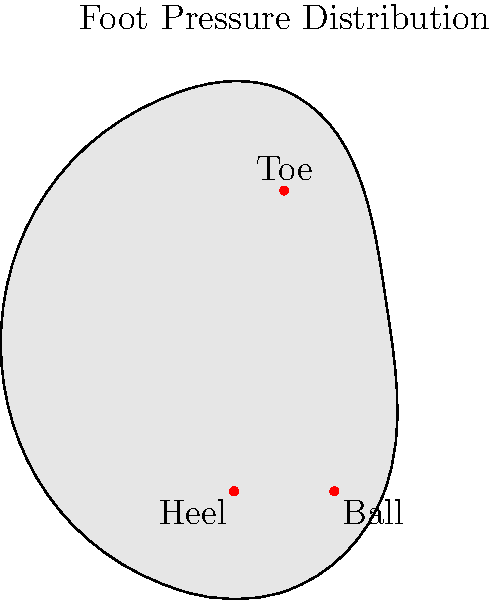When standing for extended periods, which area of the foot typically experiences the highest pressure, as illustrated in the diagram? To understand the pressure distribution on feet when standing for long periods, let's consider the anatomy and function of the foot:

1. The foot has three main weight-bearing areas: the heel, the ball (metatarsal heads), and the toes.

2. When standing, body weight is distributed across these areas, but not equally.

3. The heel and ball of the foot are designed to bear more weight than the toes.

4. The heel has a thick fat pad to absorb shock and pressure.

5. The ball of the foot, specifically the metatarsal heads, bears a significant portion of the body's weight during standing.

6. The arch of the foot helps distribute weight between the heel and ball.

7. In prolonged standing, the body's weight shifts more towards the front of the foot to maintain balance.

8. This shift increases pressure on the ball of the foot over time.

9. The toes, while important for balance, bear less weight than the heel or ball.

Given these factors, when standing for long periods, the ball of the foot typically experiences the highest pressure. This is because it bears a large portion of the body's weight and becomes increasingly loaded as the person maintains their standing position over time.
Answer: Ball of the foot 